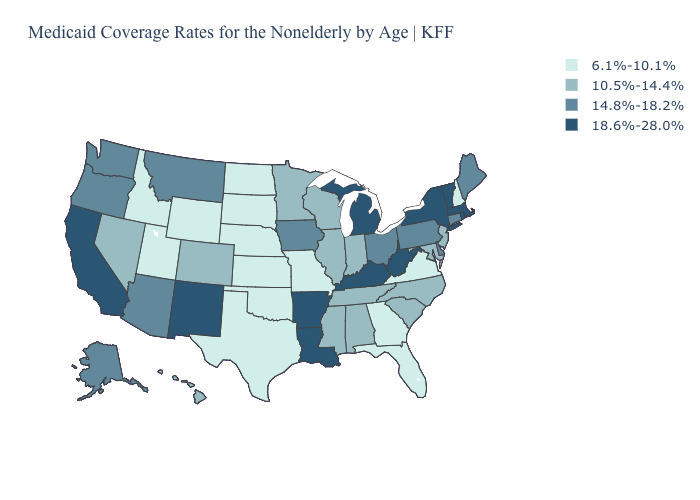Does Texas have the lowest value in the South?
Answer briefly. Yes. What is the highest value in the USA?
Short answer required. 18.6%-28.0%. Name the states that have a value in the range 14.8%-18.2%?
Write a very short answer. Alaska, Arizona, Connecticut, Delaware, Iowa, Maine, Montana, Ohio, Oregon, Pennsylvania, Washington. What is the value of Pennsylvania?
Concise answer only. 14.8%-18.2%. What is the highest value in the MidWest ?
Quick response, please. 18.6%-28.0%. Name the states that have a value in the range 14.8%-18.2%?
Give a very brief answer. Alaska, Arizona, Connecticut, Delaware, Iowa, Maine, Montana, Ohio, Oregon, Pennsylvania, Washington. Does Alabama have a lower value than Kentucky?
Quick response, please. Yes. Which states have the highest value in the USA?
Short answer required. Arkansas, California, Kentucky, Louisiana, Massachusetts, Michigan, New Mexico, New York, Rhode Island, Vermont, West Virginia. What is the value of Utah?
Write a very short answer. 6.1%-10.1%. Does Vermont have a higher value than Louisiana?
Concise answer only. No. Does Tennessee have the same value as Minnesota?
Answer briefly. Yes. Among the states that border Oklahoma , does New Mexico have the highest value?
Quick response, please. Yes. Among the states that border Nevada , does Oregon have the highest value?
Keep it brief. No. What is the value of New Hampshire?
Answer briefly. 6.1%-10.1%. 